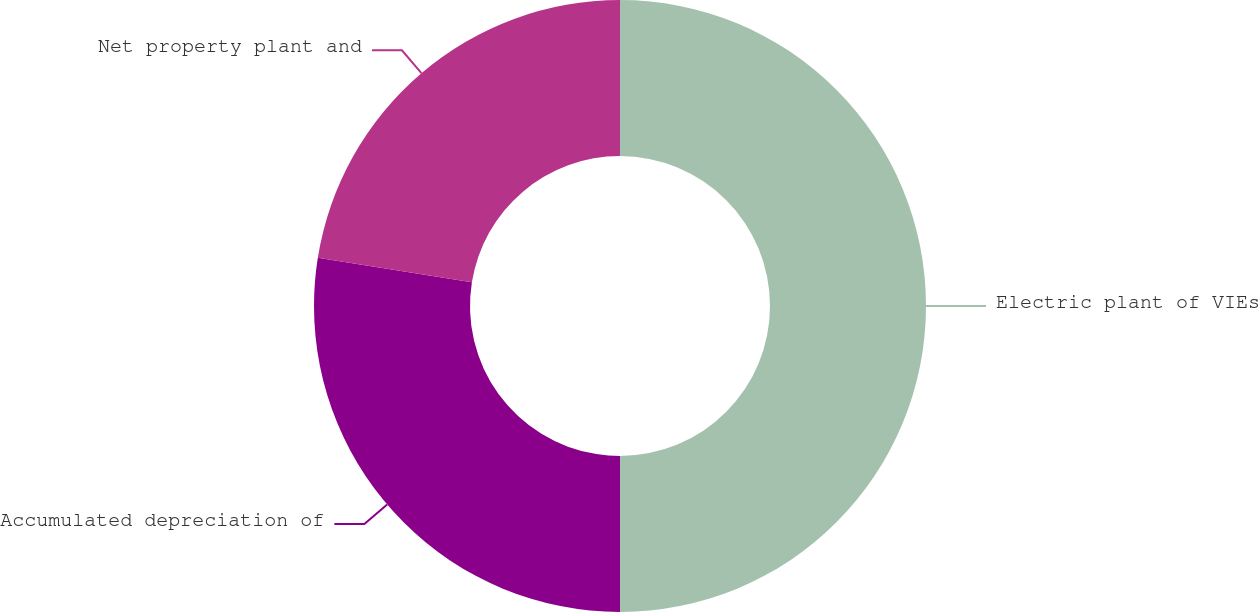Convert chart to OTSL. <chart><loc_0><loc_0><loc_500><loc_500><pie_chart><fcel>Electric plant of VIEs<fcel>Accumulated depreciation of<fcel>Net property plant and<nl><fcel>50.0%<fcel>27.52%<fcel>22.48%<nl></chart> 